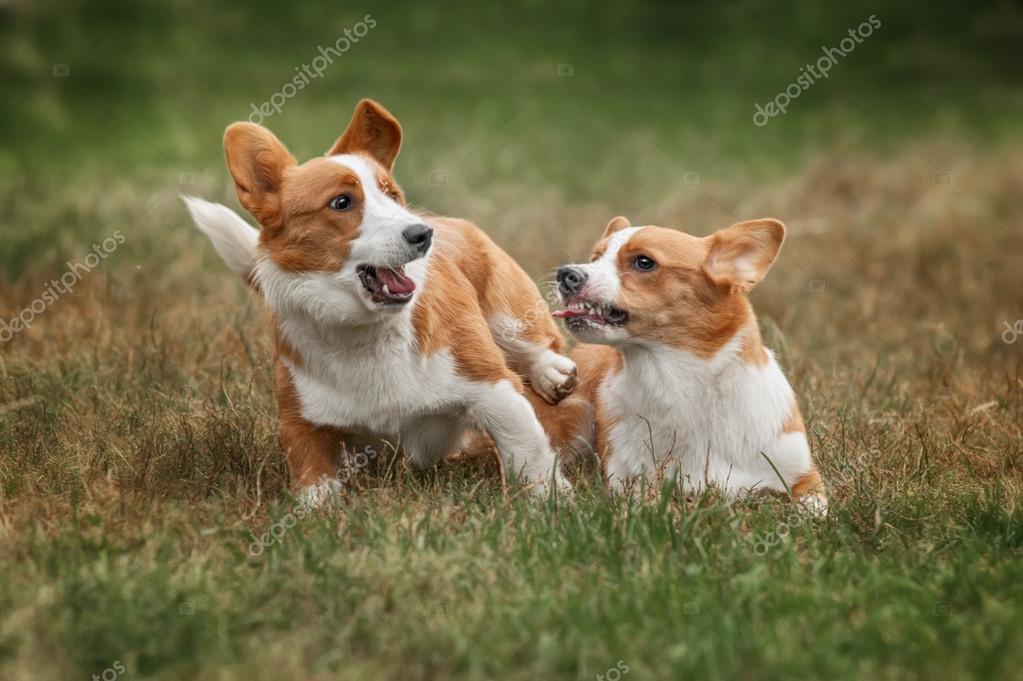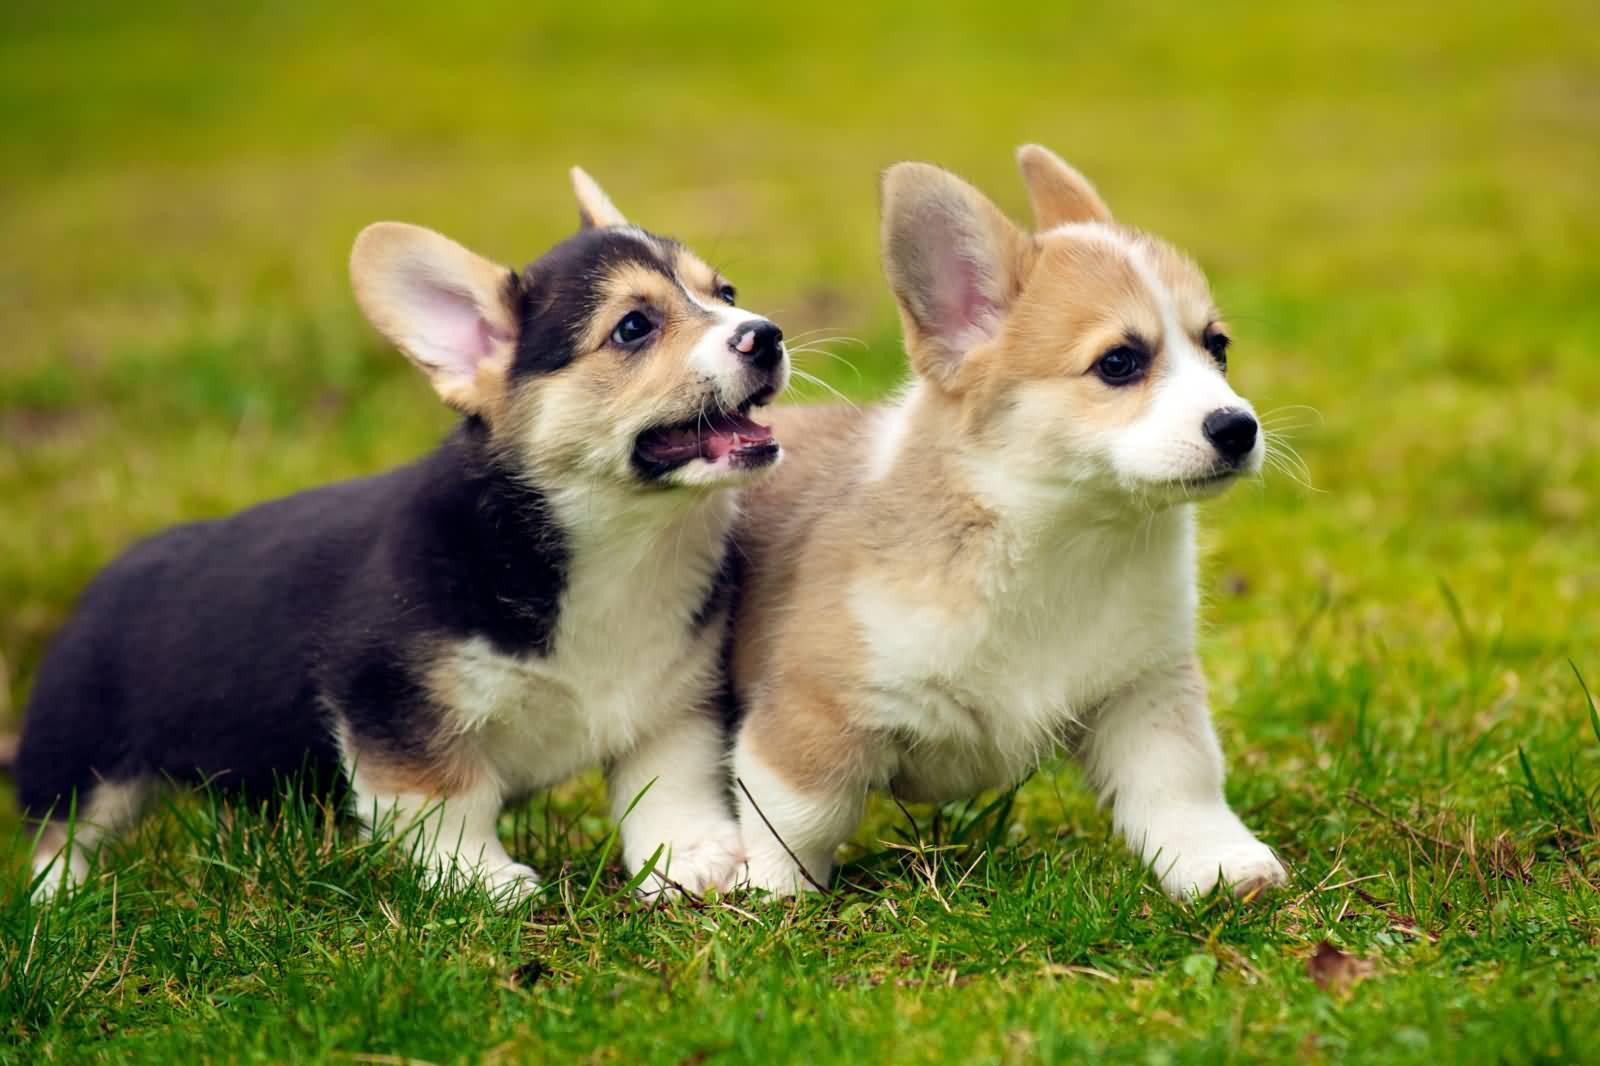The first image is the image on the left, the second image is the image on the right. Given the left and right images, does the statement "Two of the corgis are running with their mouths hanging open, the other two are sitting facing towards the camera." hold true? Answer yes or no. No. 